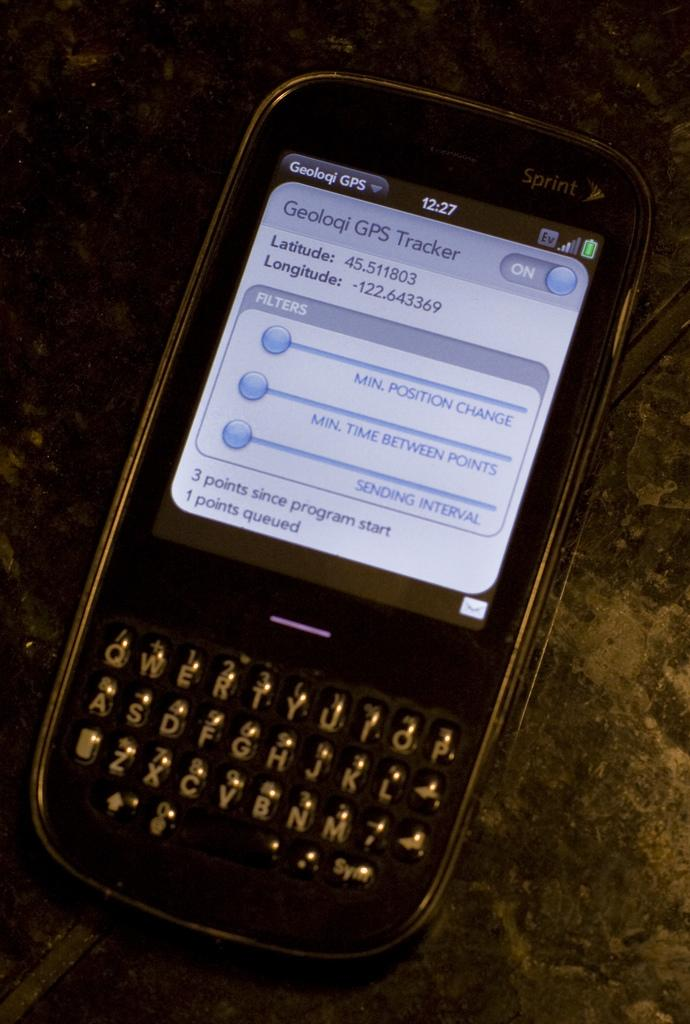<image>
Render a clear and concise summary of the photo. The screen of a Sprint cell phone displays latitude and longitude locations. 